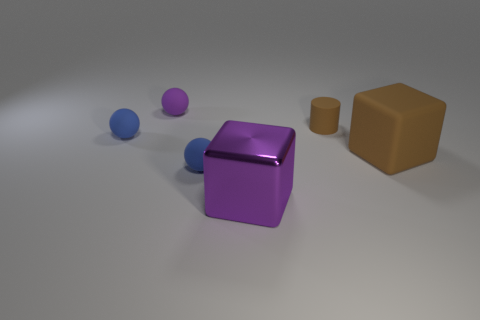Add 3 small brown matte things. How many objects exist? 9 Subtract all blocks. How many objects are left? 4 Subtract all yellow cylinders. Subtract all matte balls. How many objects are left? 3 Add 6 blue rubber objects. How many blue rubber objects are left? 8 Add 6 tiny brown matte cylinders. How many tiny brown matte cylinders exist? 7 Subtract 0 red blocks. How many objects are left? 6 